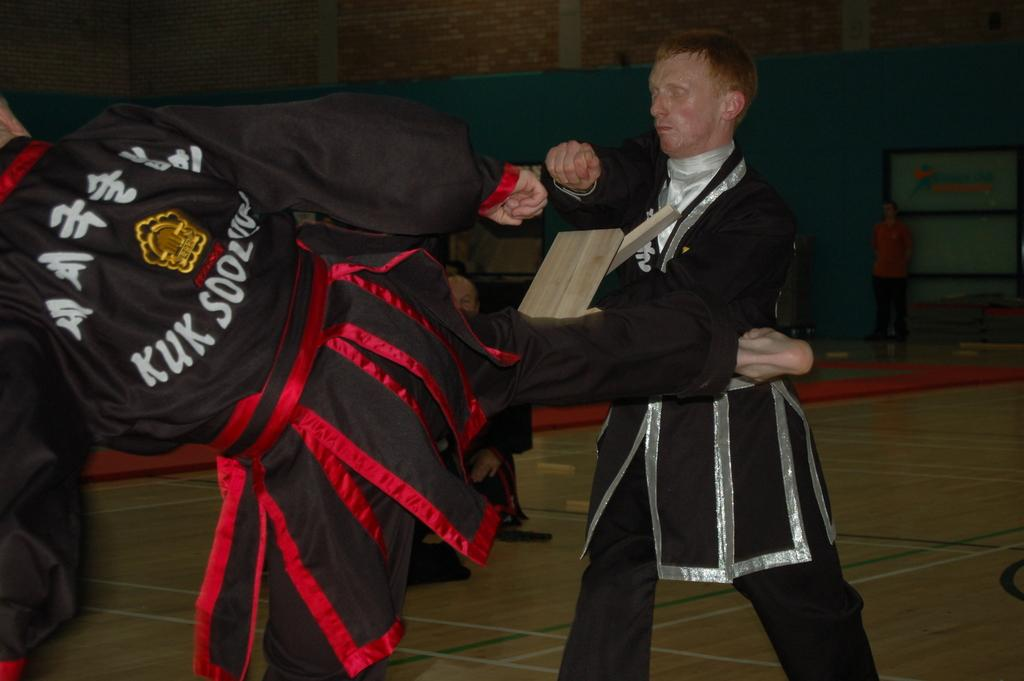<image>
Write a terse but informative summary of the picture. A karate member with a Kuk Sool outfit on kicks and breaks a board held by another man. 